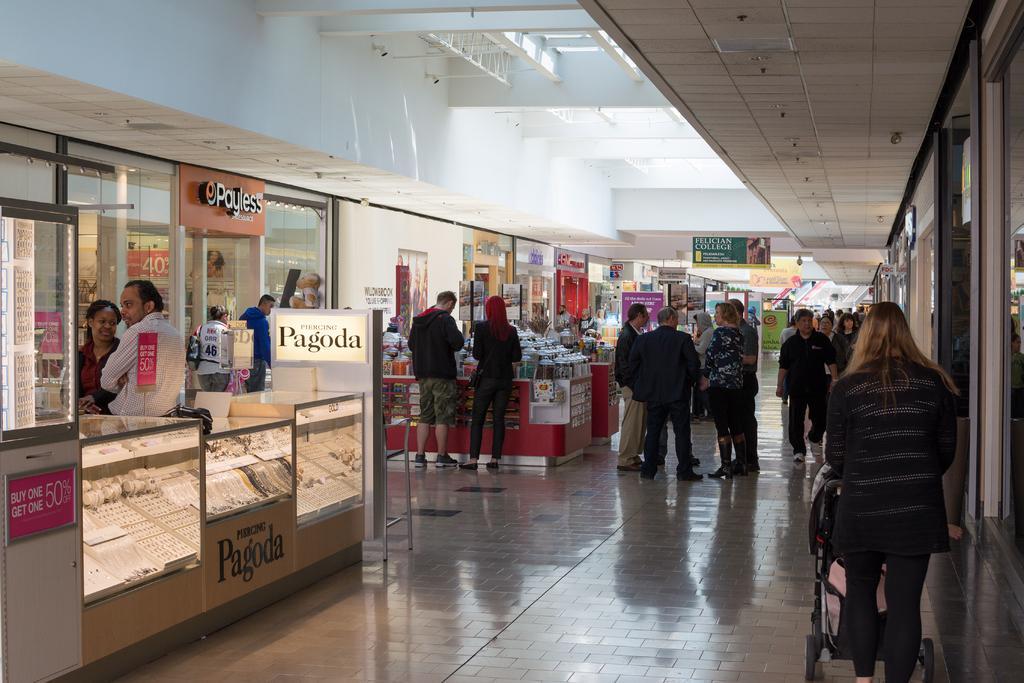Please provide a concise description of this image. In the image it looks like some shopping complex, there are plenty of stores and there are many people buying the objects by standing around those stores and on the right side there is a woman carrying a baby in a trolley. 